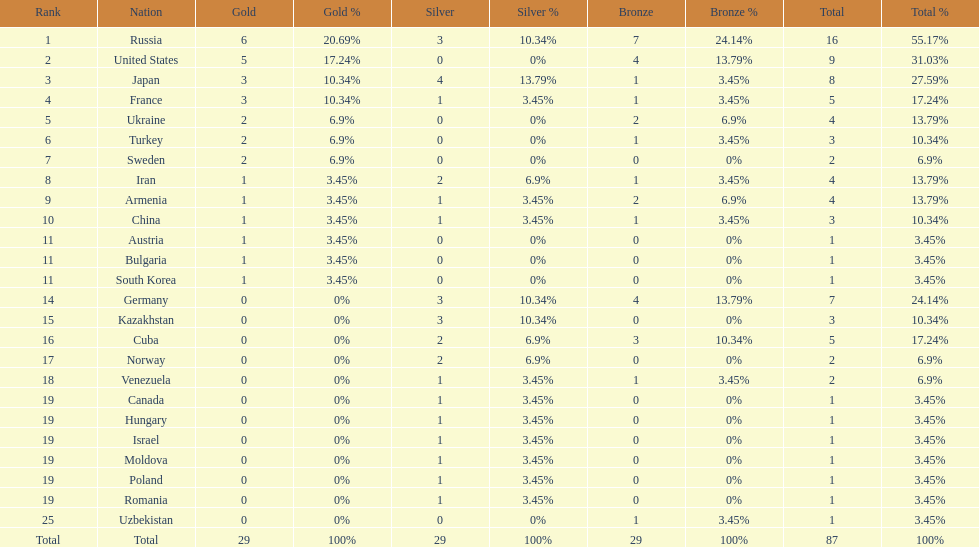Which nation has one gold medal but zero in both silver and bronze? Austria. 